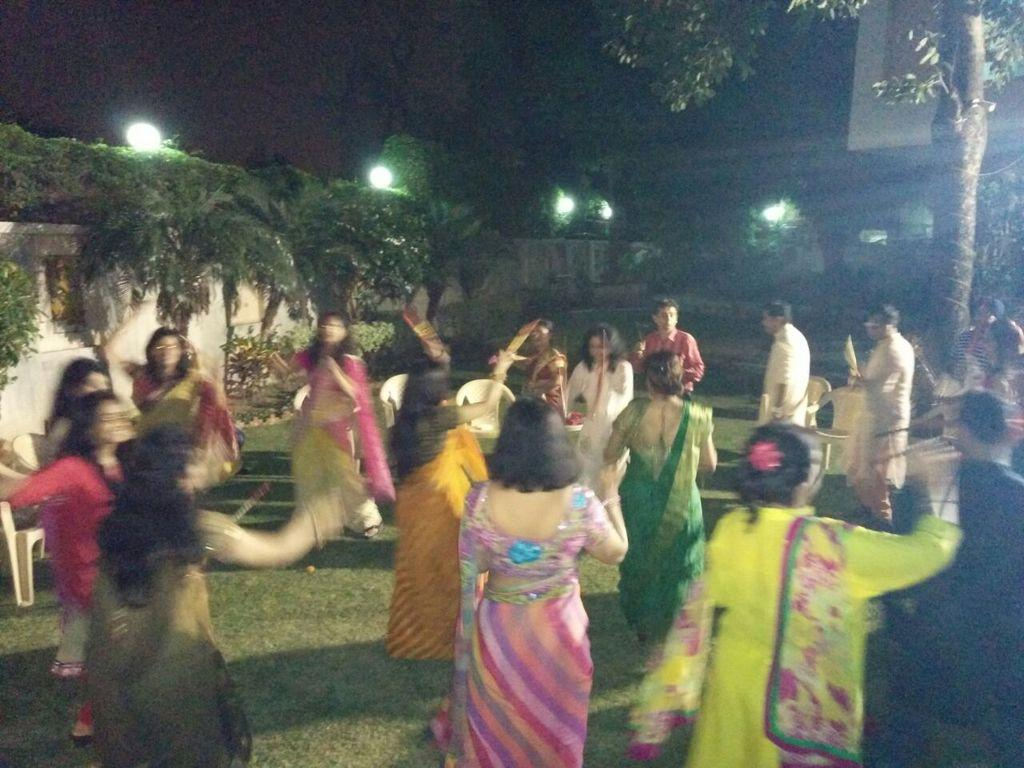What is happening in the image involving the group of people? The people in the image are dancing. Can you describe the attire of one of the individuals in the group? There is a person wearing a multi-color saree in the image. What can be seen in the background of the image? There are trees and plants in the background of the image. What color are the plants in the image? The plants in the image are green. What else is visible in the image? There are lights visible in the image. Can you tell me how many goldfish are swimming in the bucket in the image? There is no bucket or goldfish present in the image. What type of crayon is being used by the person wearing the multi-color saree in the image? There is no crayon visible in the image, and the person wearing the multi-color saree is dancing, not using a crayon. 